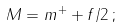<formula> <loc_0><loc_0><loc_500><loc_500>M = m ^ { + } + f / 2 \, ;</formula> 